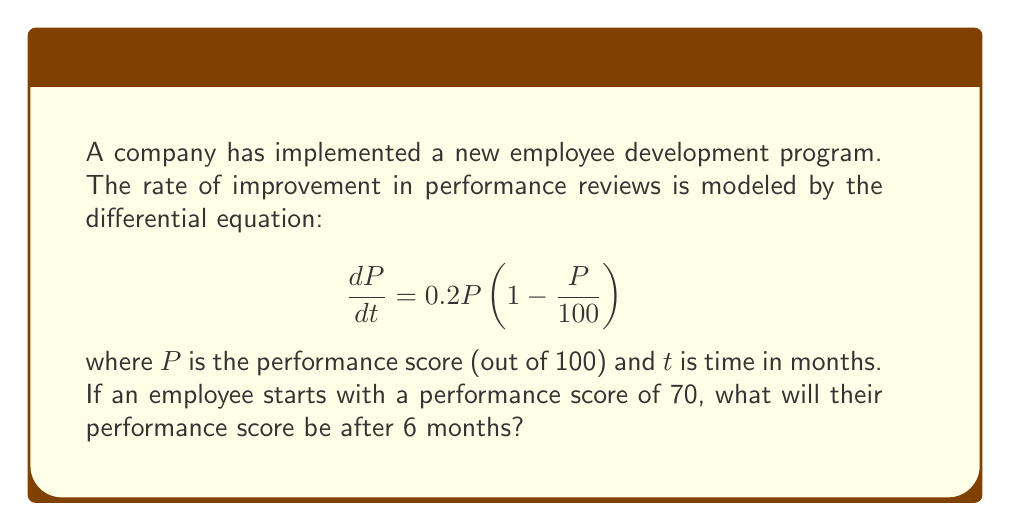Teach me how to tackle this problem. To solve this problem, we need to use the logistic growth model, which is a first-order differential equation. Let's approach this step-by-step:

1) The given differential equation is in the form of the logistic growth model:
   $$\frac{dP}{dt} = rP(1 - \frac{P}{K})$$
   where $r = 0.2$ (growth rate) and $K = 100$ (carrying capacity).

2) The solution to this differential equation is:
   $$P(t) = \frac{K}{1 + (\frac{K}{P_0} - 1)e^{-rt}}$$
   where $P_0$ is the initial performance score.

3) We're given that $P_0 = 70$, $K = 100$, $r = 0.2$, and we need to find $P(6)$.

4) Let's substitute these values into our solution:
   $$P(6) = \frac{100}{1 + (\frac{100}{70} - 1)e^{-0.2(6)}}$$

5) Simplify:
   $$P(6) = \frac{100}{1 + (\frac{10}{7} - 1)e^{-1.2}}$$
   $$= \frac{100}{1 + (\frac{3}{7})e^{-1.2}}$$

6) Calculate $e^{-1.2} \approx 0.3012$

7) Substitute and calculate:
   $$P(6) = \frac{100}{1 + (\frac{3}{7})(0.3012)}$$
   $$= \frac{100}{1 + 0.1291}$$
   $$= \frac{100}{1.1291}$$
   $$\approx 88.57$$

Therefore, after 6 months, the employee's performance score will be approximately 88.57.
Answer: $P(6) \approx 88.57$ 